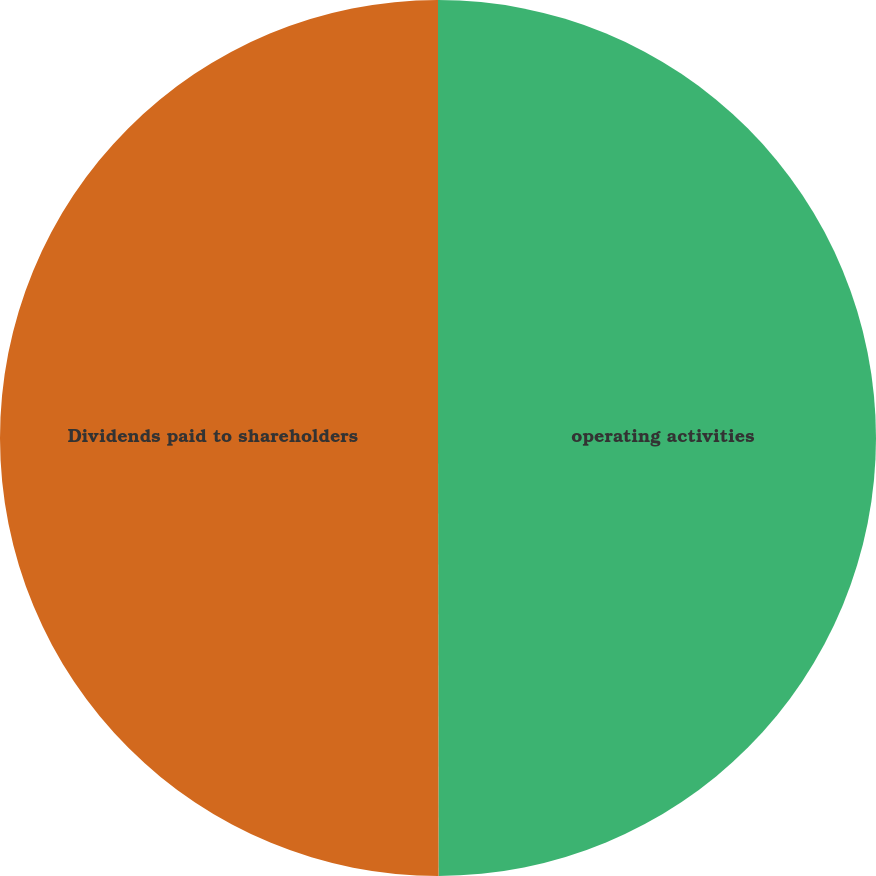<chart> <loc_0><loc_0><loc_500><loc_500><pie_chart><fcel>operating activities<fcel>Dividends paid to shareholders<nl><fcel>49.98%<fcel>50.02%<nl></chart> 